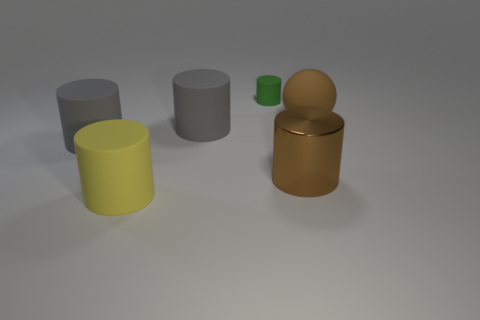What is the material of the large sphere?
Provide a succinct answer. Rubber. Are there any brown objects behind the green matte object?
Provide a succinct answer. No. There is a big gray rubber cylinder to the left of the large yellow cylinder; how many brown metal objects are to the right of it?
Offer a terse response. 1. There is a yellow cylinder that is the same size as the ball; what is its material?
Your answer should be very brief. Rubber. How many other things are there of the same material as the small cylinder?
Provide a short and direct response. 4. What number of large brown metal things are in front of the brown rubber object?
Your answer should be very brief. 1. How many balls are either large metallic objects or large brown rubber objects?
Your answer should be compact. 1. What is the size of the matte thing that is on the right side of the yellow cylinder and to the left of the tiny green cylinder?
Make the answer very short. Large. How many other objects are there of the same color as the matte sphere?
Offer a very short reply. 1. Are the yellow cylinder and the large brown object that is right of the brown shiny thing made of the same material?
Your answer should be compact. Yes. 